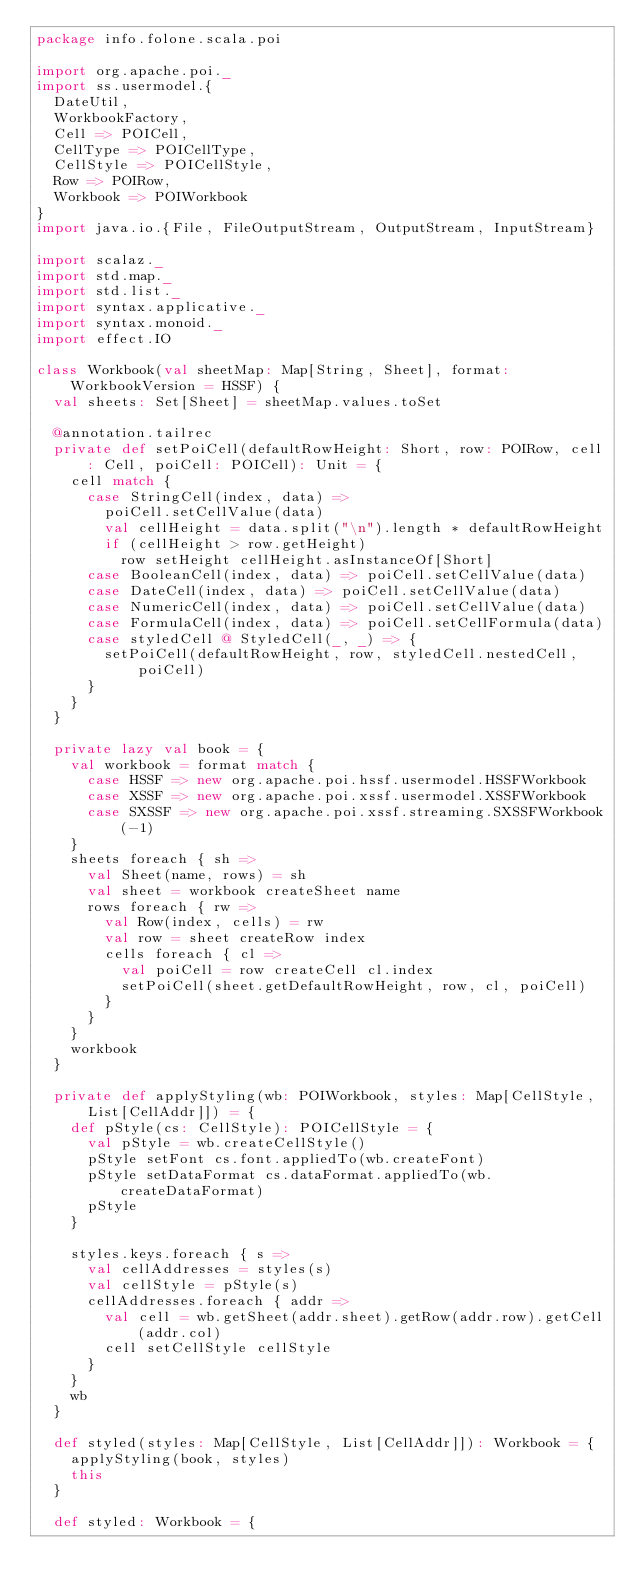Convert code to text. <code><loc_0><loc_0><loc_500><loc_500><_Scala_>package info.folone.scala.poi

import org.apache.poi._
import ss.usermodel.{
  DateUtil,
  WorkbookFactory,
  Cell => POICell,
  CellType => POICellType,
  CellStyle => POICellStyle,
  Row => POIRow,
  Workbook => POIWorkbook
}
import java.io.{File, FileOutputStream, OutputStream, InputStream}

import scalaz._
import std.map._
import std.list._
import syntax.applicative._
import syntax.monoid._
import effect.IO

class Workbook(val sheetMap: Map[String, Sheet], format: WorkbookVersion = HSSF) {
  val sheets: Set[Sheet] = sheetMap.values.toSet

  @annotation.tailrec
  private def setPoiCell(defaultRowHeight: Short, row: POIRow, cell: Cell, poiCell: POICell): Unit = {
    cell match {
      case StringCell(index, data) =>
        poiCell.setCellValue(data)
        val cellHeight = data.split("\n").length * defaultRowHeight
        if (cellHeight > row.getHeight)
          row setHeight cellHeight.asInstanceOf[Short]
      case BooleanCell(index, data) => poiCell.setCellValue(data)
      case DateCell(index, data) => poiCell.setCellValue(data)
      case NumericCell(index, data) => poiCell.setCellValue(data)
      case FormulaCell(index, data) => poiCell.setCellFormula(data)
      case styledCell @ StyledCell(_, _) => {
        setPoiCell(defaultRowHeight, row, styledCell.nestedCell, poiCell)
      }
    }
  }

  private lazy val book = {
    val workbook = format match {
      case HSSF => new org.apache.poi.hssf.usermodel.HSSFWorkbook
      case XSSF => new org.apache.poi.xssf.usermodel.XSSFWorkbook
      case SXSSF => new org.apache.poi.xssf.streaming.SXSSFWorkbook(-1)
    }
    sheets foreach { sh =>
      val Sheet(name, rows) = sh
      val sheet = workbook createSheet name
      rows foreach { rw =>
        val Row(index, cells) = rw
        val row = sheet createRow index
        cells foreach { cl =>
          val poiCell = row createCell cl.index
          setPoiCell(sheet.getDefaultRowHeight, row, cl, poiCell)
        }
      }
    }
    workbook
  }

  private def applyStyling(wb: POIWorkbook, styles: Map[CellStyle, List[CellAddr]]) = {
    def pStyle(cs: CellStyle): POICellStyle = {
      val pStyle = wb.createCellStyle()
      pStyle setFont cs.font.appliedTo(wb.createFont)
      pStyle setDataFormat cs.dataFormat.appliedTo(wb.createDataFormat)
      pStyle
    }

    styles.keys.foreach { s =>
      val cellAddresses = styles(s)
      val cellStyle = pStyle(s)
      cellAddresses.foreach { addr =>
        val cell = wb.getSheet(addr.sheet).getRow(addr.row).getCell(addr.col)
        cell setCellStyle cellStyle
      }
    }
    wb
  }

  def styled(styles: Map[CellStyle, List[CellAddr]]): Workbook = {
    applyStyling(book, styles)
    this
  }

  def styled: Workbook = {</code> 